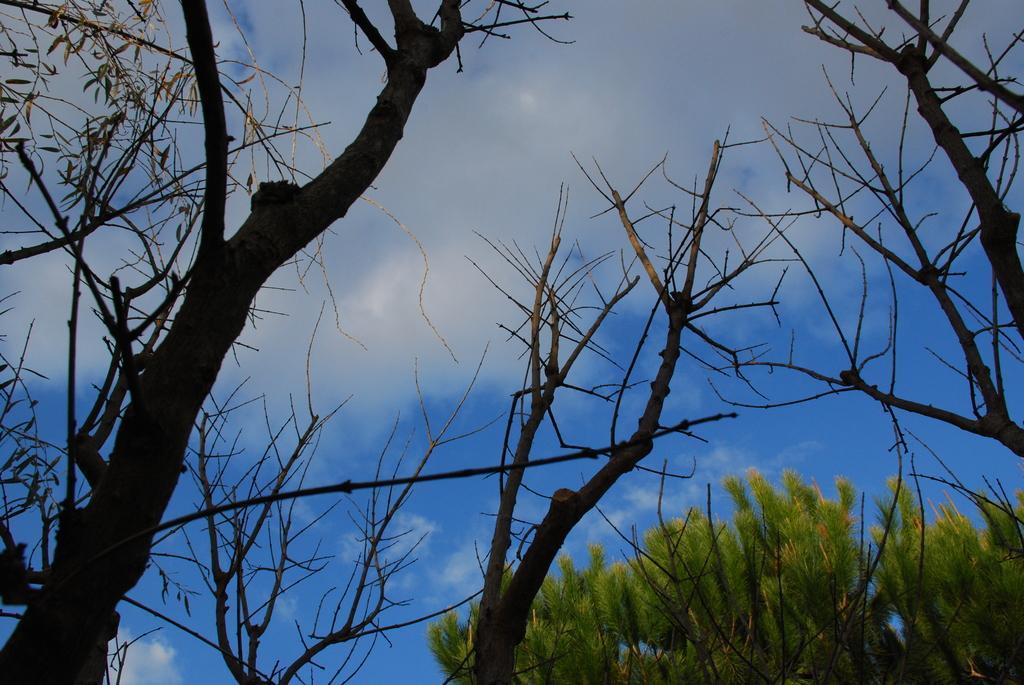Please provide a concise description of this image. In this image we can see many trees. At the top we can see the clear sky. 